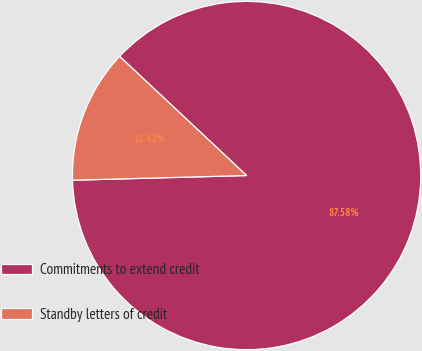Convert chart to OTSL. <chart><loc_0><loc_0><loc_500><loc_500><pie_chart><fcel>Commitments to extend credit<fcel>Standby letters of credit<nl><fcel>87.58%<fcel>12.42%<nl></chart> 